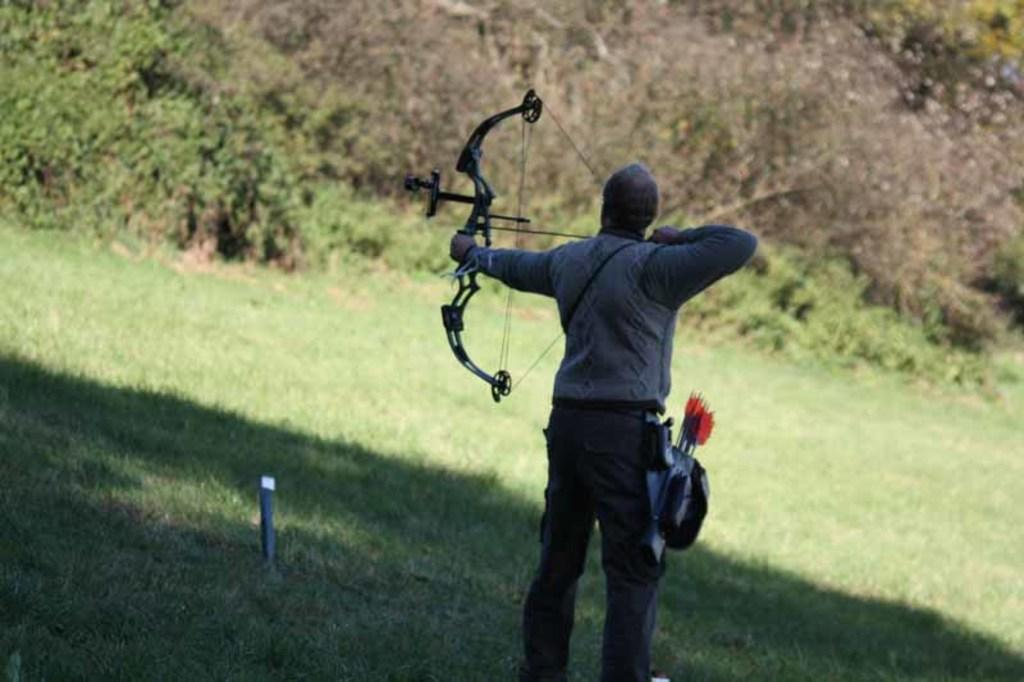Who or what is the main subject in the image? There is a person in the image. What is the person wearing? The person is wearing clothes. What is the person doing in the image? The person is shooting an arrow. What can be seen at the top of the image? There are plants at the top of the image. What type of attraction is the person visiting in the image? There is no indication of an attraction in the image; it features a person shooting an arrow. What role does zinc play in the image? There is no mention of zinc in the image; it is focused on a person shooting an arrow and plants at the top. 